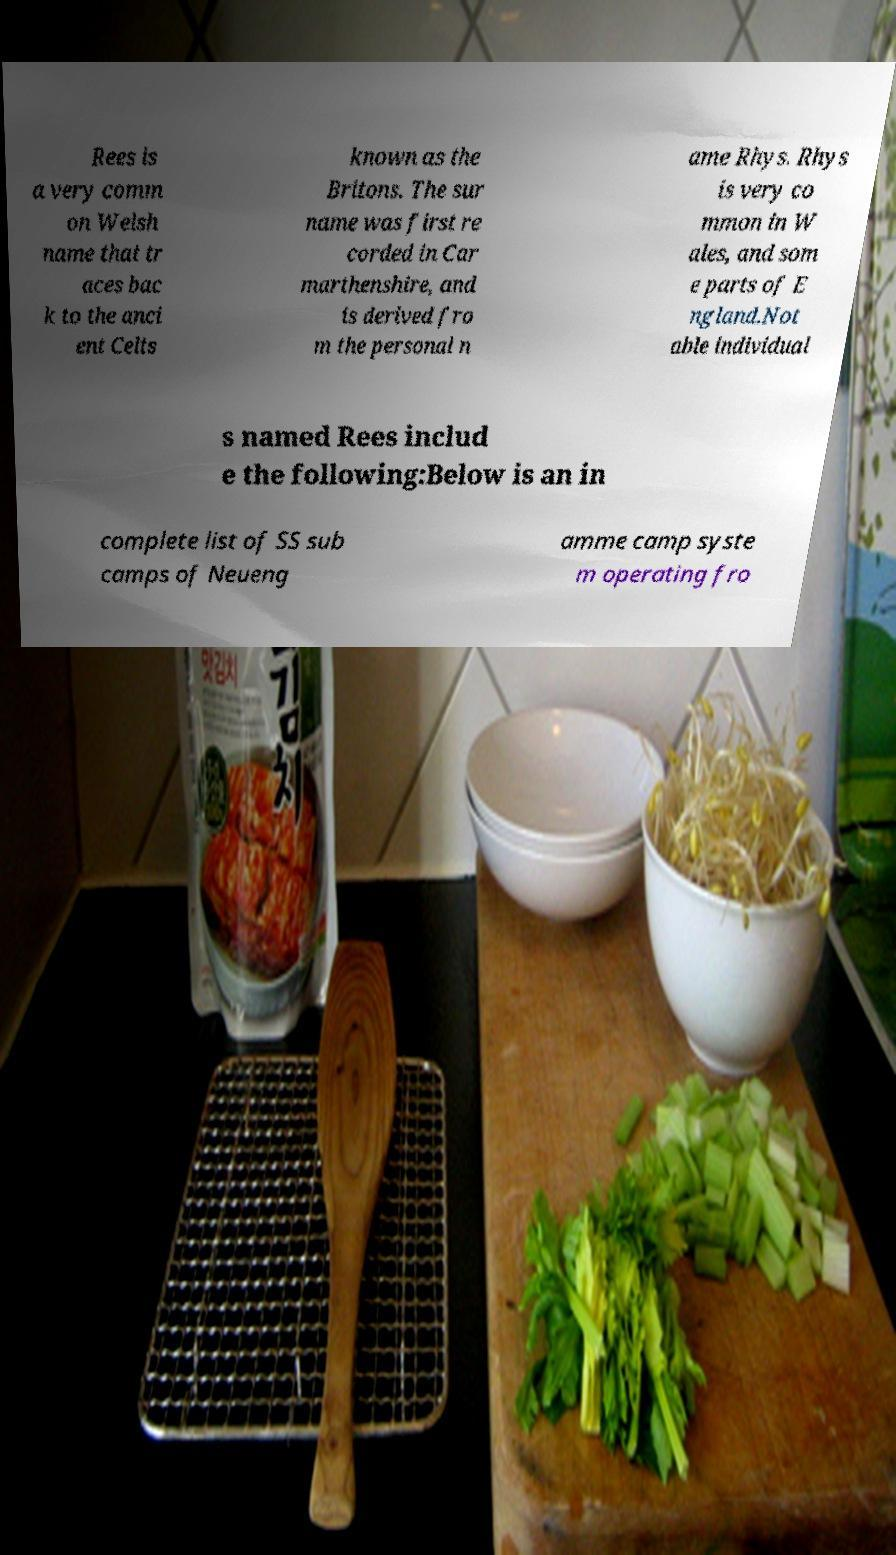Could you assist in decoding the text presented in this image and type it out clearly? Rees is a very comm on Welsh name that tr aces bac k to the anci ent Celts known as the Britons. The sur name was first re corded in Car marthenshire, and is derived fro m the personal n ame Rhys. Rhys is very co mmon in W ales, and som e parts of E ngland.Not able individual s named Rees includ e the following:Below is an in complete list of SS sub camps of Neueng amme camp syste m operating fro 